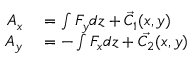Convert formula to latex. <formula><loc_0><loc_0><loc_500><loc_500>\begin{array} { r l } { A _ { x } } & = \int F _ { y } d z + { \vec { C _ { 1 } } } ( x , y ) } \\ { A _ { y } } & = - \int F _ { x } d z + { \vec { C _ { 2 } } } ( x , y ) } \end{array}</formula> 